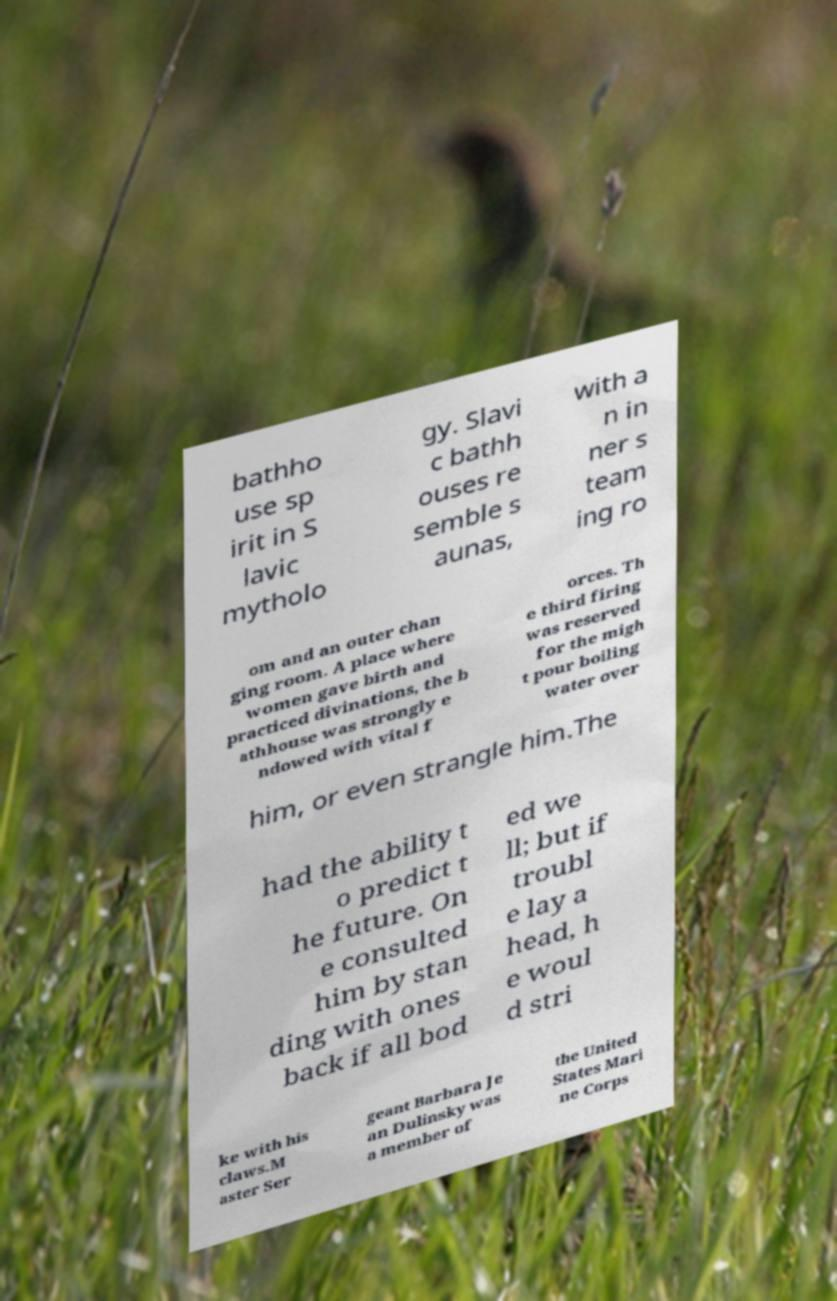Please identify and transcribe the text found in this image. bathho use sp irit in S lavic mytholo gy. Slavi c bathh ouses re semble s aunas, with a n in ner s team ing ro om and an outer chan ging room. A place where women gave birth and practiced divinations, the b athhouse was strongly e ndowed with vital f orces. Th e third firing was reserved for the migh t pour boiling water over him, or even strangle him.The had the ability t o predict t he future. On e consulted him by stan ding with ones back if all bod ed we ll; but if troubl e lay a head, h e woul d stri ke with his claws.M aster Ser geant Barbara Je an Dulinsky was a member of the United States Mari ne Corps 